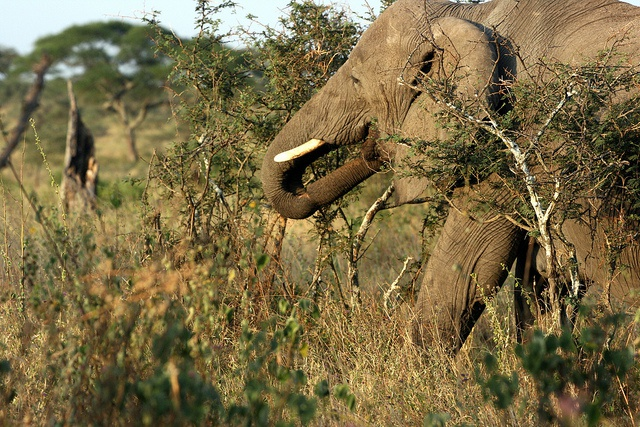Describe the objects in this image and their specific colors. I can see a elephant in white, tan, black, and olive tones in this image. 